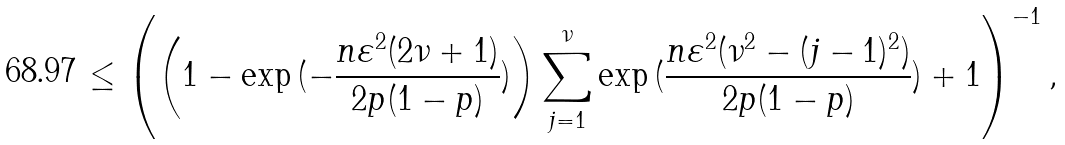<formula> <loc_0><loc_0><loc_500><loc_500>\leq \left ( \left ( 1 - \exp { ( - \frac { n \varepsilon ^ { 2 } ( 2 \nu + 1 ) } { 2 p ( 1 - p ) } ) } \right ) \sum _ { j = 1 } ^ { \nu } \exp { ( \frac { n \varepsilon ^ { 2 } ( \nu ^ { 2 } - ( j - 1 ) ^ { 2 } ) } { 2 p ( 1 - p ) } ) } + 1 \right ) ^ { - 1 } ,</formula> 